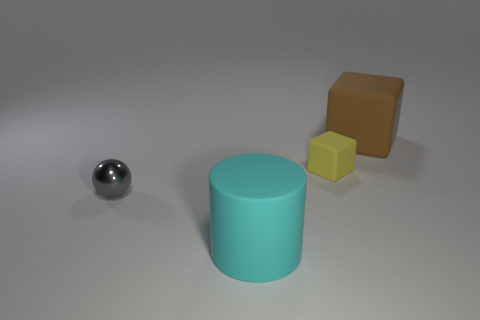Add 3 big cyan cubes. How many objects exist? 7 Subtract all balls. How many objects are left? 3 Add 2 large cylinders. How many large cylinders are left? 3 Add 4 red rubber cylinders. How many red rubber cylinders exist? 4 Subtract all yellow blocks. How many blocks are left? 1 Subtract 0 cyan cubes. How many objects are left? 4 Subtract 1 spheres. How many spheres are left? 0 Subtract all purple blocks. Subtract all gray spheres. How many blocks are left? 2 Subtract all brown cylinders. How many brown spheres are left? 0 Subtract all brown matte balls. Subtract all matte blocks. How many objects are left? 2 